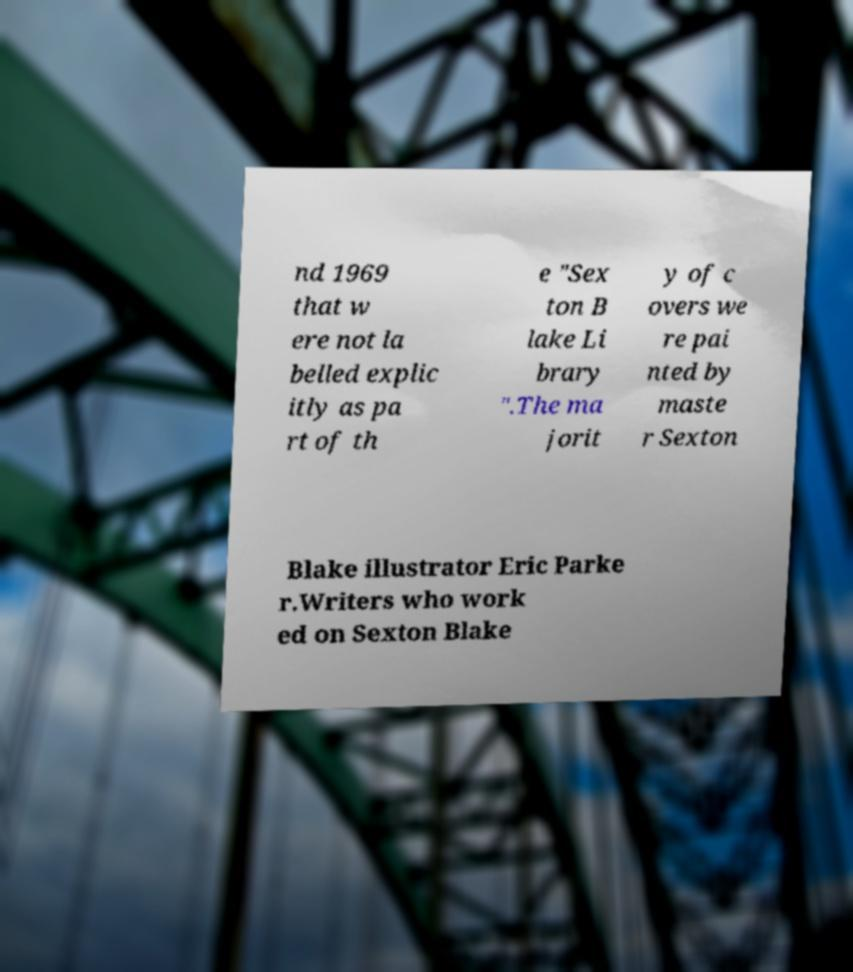Please identify and transcribe the text found in this image. nd 1969 that w ere not la belled explic itly as pa rt of th e "Sex ton B lake Li brary ".The ma jorit y of c overs we re pai nted by maste r Sexton Blake illustrator Eric Parke r.Writers who work ed on Sexton Blake 